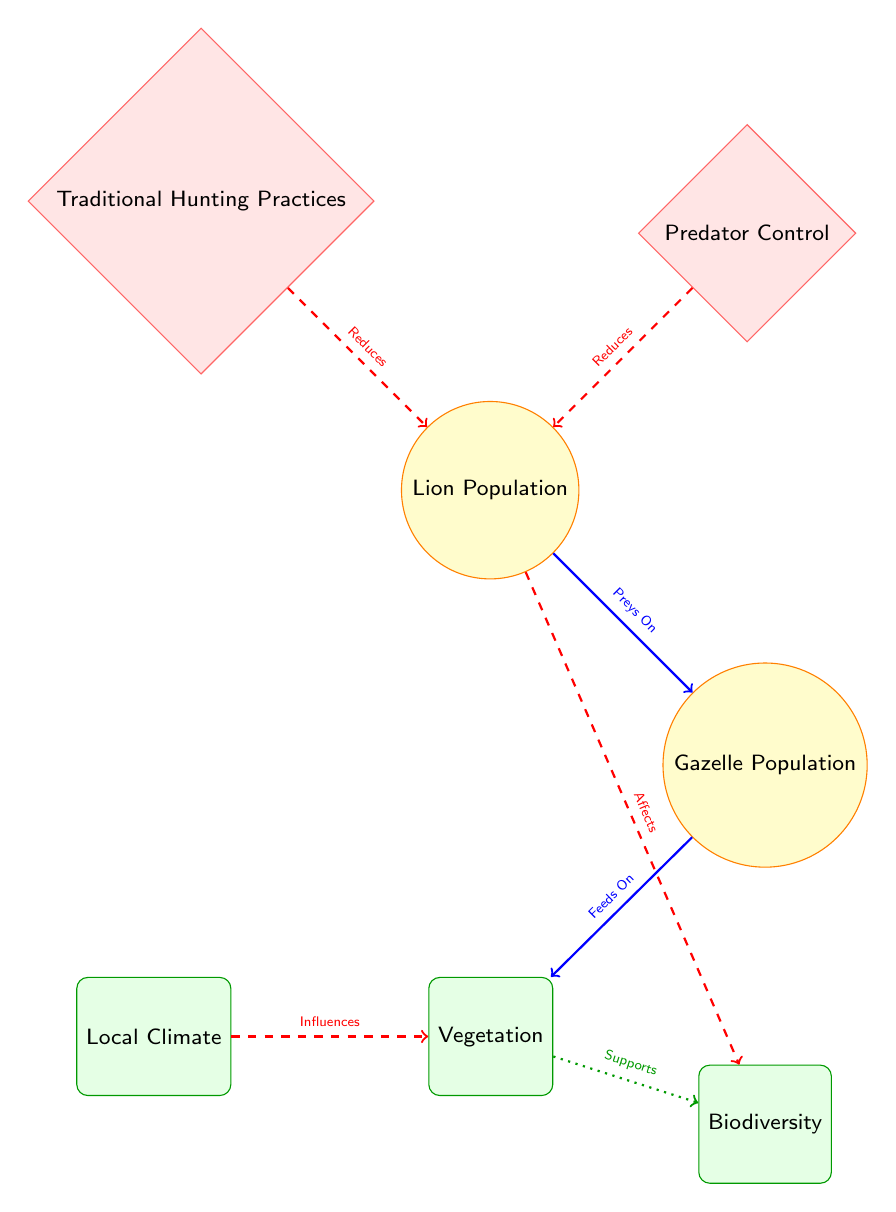What are the two species represented in the diagram? The diagram explicitly shows two species represented by circles: Lion Population and Gazelle Population.
Answer: Lion Population, Gazelle Population How many human activity nodes are present in the diagram? There are two human activity nodes represented as diamonds: Traditional Hunting Practices and Predator Control.
Answer: 2 What is the relationship between lion population and gazelle population? The arrow labeled "Preys On" indicates that the lion population preys on the gazelle population, illustrating the predator-prey relationship.
Answer: Preys On What does traditional hunting practices reduce? The dashed arrow from Traditional Hunting Practices labeled "Reduces" points to Lion Population, indicating that these practices reduce the lion population.
Answer: Lion Population Which environmental factor directly influences vegetation? The arrow from Local Climate to Vegetation labeled "Influences" shows the direct influence of the local climate on vegetation.
Answer: Local Climate What is supported by vegetation according to the diagram? The green dotted arrow from Vegetation to Biodiversity labeled "Supports" indicates that vegetation supports biodiversity.
Answer: Biodiversity How does lion population affect biodiversity? The diagram shows an impact relationship where the lion population "Affects" biodiversity, meaning changes in lion populations influence biodiversity levels.
Answer: Affects What is the main impact of predator control on the lion population? The dashed arrow labeled "Reduces" shows that predator control practices also serve to reduce the lion population, similar to traditional hunting.
Answer: Reduces How many ecological factors are represented in the diagram? There are four environmental nodes represented: Vegetation, Biodiversity, Local Climate, and Lion Population serving as the primary focus, summing up to four ecological factors.
Answer: 4 